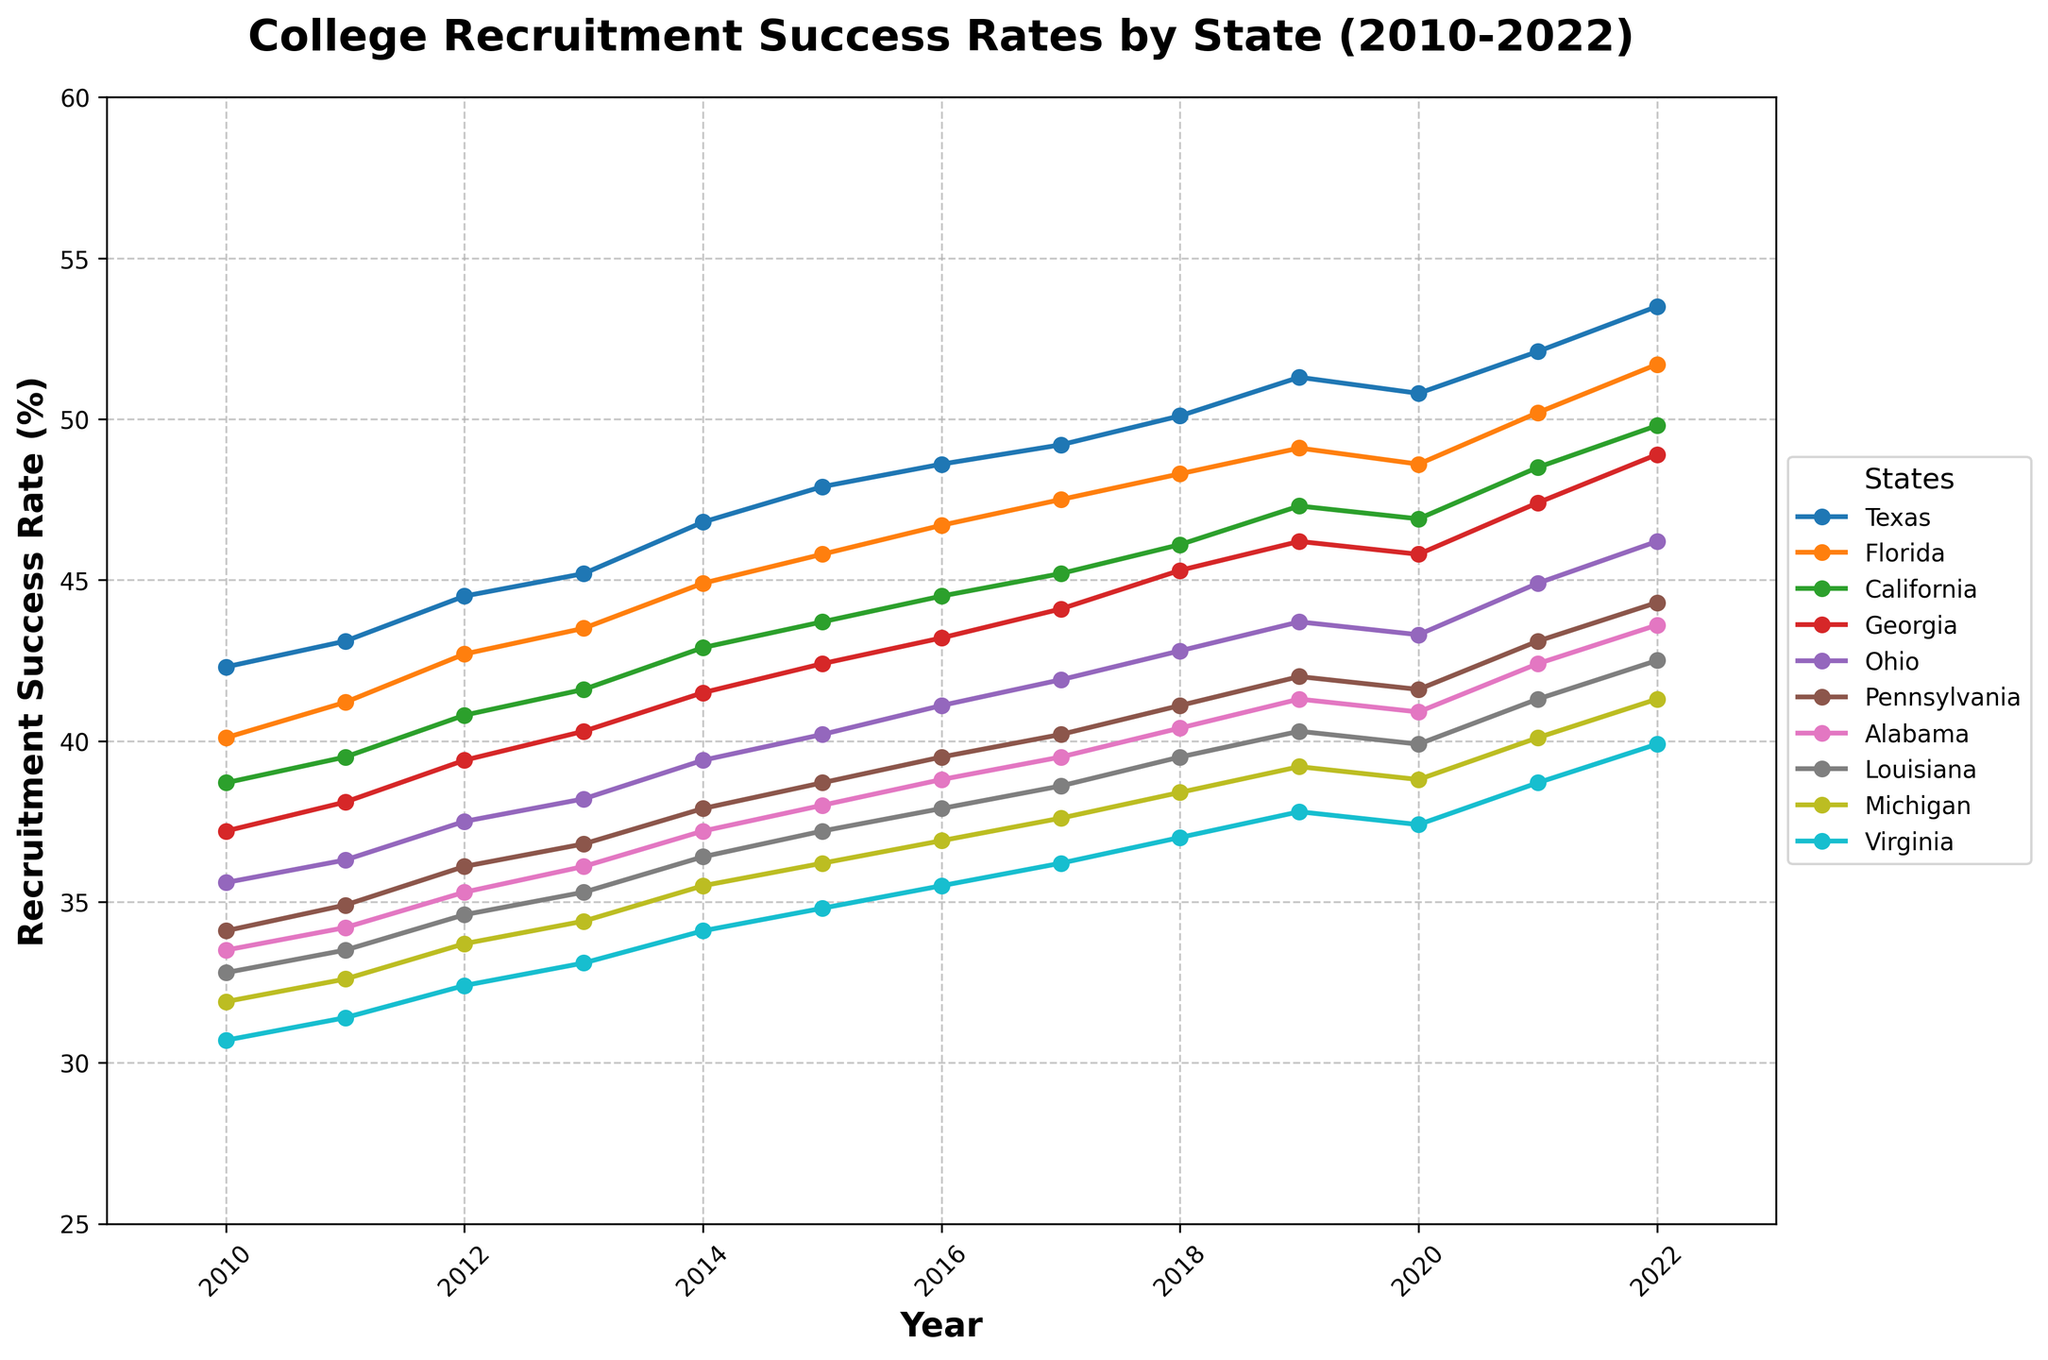Which state had the highest recruitment success rate in 2022? To determine which state had the highest recruitment success rate in 2022, look at the endpoints of each line where they intersect with the year 2022 and find the highest point. Texas has the highest endpoint in 2022.
Answer: Texas Between 2016 and 2018, which state showed the greatest increase in recruitment success rate? Calculate the difference between the 2016 and 2018 recruitment success rates for each state and find the highest difference. Texas showed an increase from 48.6% to 50.1%, an increase of 1.5, which is the greatest among all states.
Answer: Texas What is the average recruitment success rate of Alabama from 2010 to 2022? Sum the recruitment success rates of Alabama from 2010 to 2022 and divide by the number of years (13). Sum: 33.5 + 34.2 + 35.3 + 36.1 + 37.2 + 38.0 + 38.8 + 39.5 + 40.4 + 41.3 + 40.9 + 42.4 + 43.6 = 501.2. The average is 501.2/13 = 38.55.
Answer: 38.55 Which state had the smallest change in recruitment success rate from 2010 to 2022? Calculate the difference between the 2010 and 2022 recruitment success rates for each state and identify the smallest absolute difference. Virginia had a change from 30.7% to 39.9%, which is a difference of 9.2, the smallest change among all listed states.
Answer: Virginia Did any state exhibit a decline in recruitment success rate at any point from 2010 to 2022? If so, which state(s)? Look at the trends of each state's line and observe if any line shows a downward trend at any point. Ohio shows a slight decline between 2018 and 2019, from 43.7% to 43.3%, and then another slight decline in 2020 to 2021, from 43.3% to 44.9%.
Answer: Ohio Compare the recruitment success rates of California and Florida in 2011. Which state had a higher rate? Look at the 2011 data points for both California and Florida and compare them. California had a success rate of 39.5%, while Florida had 41.2%. Therefore, Florida had a higher success rate.
Answer: Florida Which state had the second-highest recruitment success rate in 2015? Look at the data points for 2015 and find the highest value. Then find the second-highest value. Texas had the highest at 47.9%, and Florida had the second-highest at 45.8%.
Answer: Florida Between 2010 and 2022, which state showed the most consistent trend in recruitment success rate? Define consistency as having the least fluctuations (ups and downs). Visually inspect the trends over the years for each state. California shows a relatively smooth and consistent upward trend without significant fluctuations.
Answer: California How did Texas' recruitment success rate trend between 2018 and 2022? Observe the Texas data points from 2018 to 2022. The values go from 50.1 in 2018 to 49.2 in 2017 to 51.3 in 2019 to 50.8 in 2020 and to 52.1 in 2021 and finally 53.5 in 2022, indicating a general upward trend.
Answer: Upward Which state showed a higher overall increase in recruitment success rate from 2010 to 2022: Ohio or Michigan? Calculate the difference between the 2010 and 2022 rates for Ohio and Michigan, respectively, and compare. Ohio: 46.2 - 35.6 = 10.6; Michigan: 41.3 - 31.9 = 9.4. Ohio had a higher increase.
Answer: Ohio 